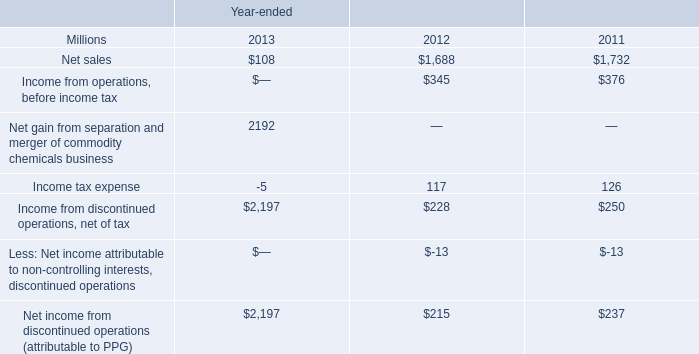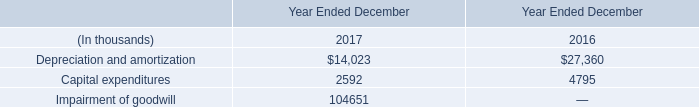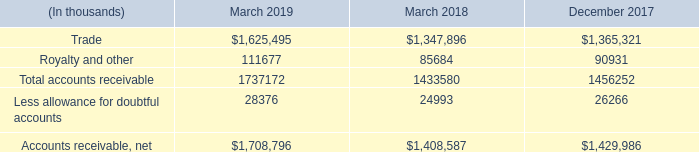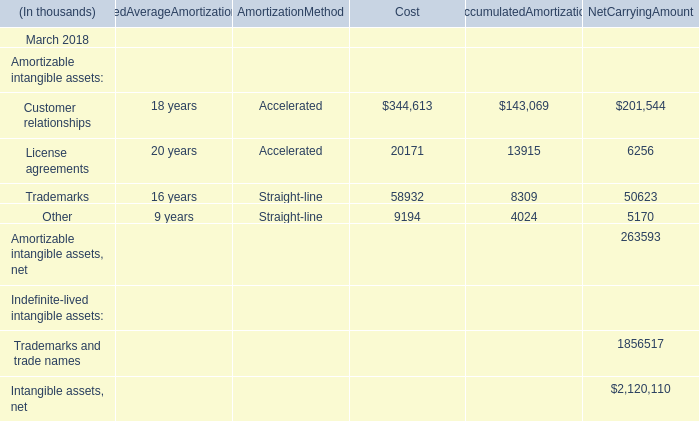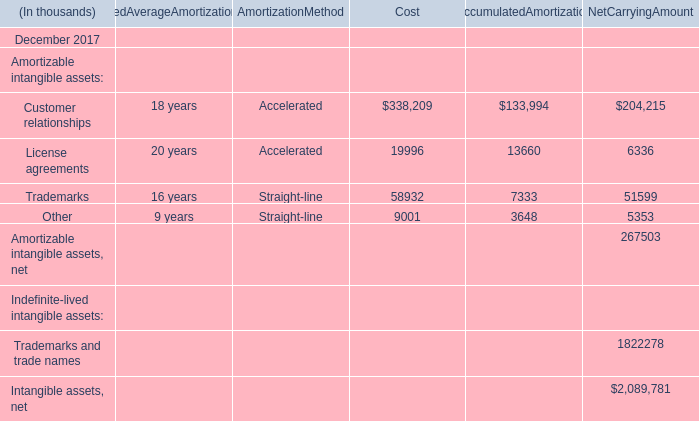What's the total value of all Cost that are in the range of 20000 and 400000 in 2017? (in thousand) 
Computations: (338209 + 58932)
Answer: 397141.0. 